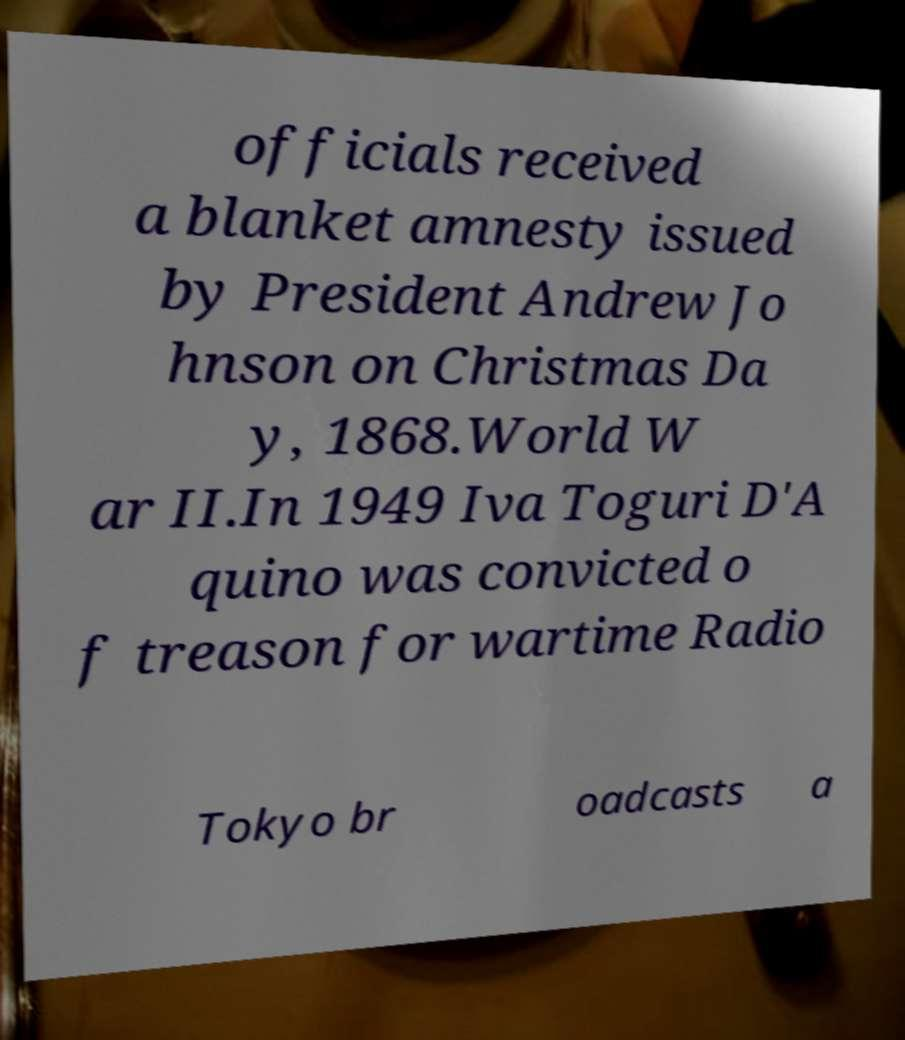What messages or text are displayed in this image? I need them in a readable, typed format. officials received a blanket amnesty issued by President Andrew Jo hnson on Christmas Da y, 1868.World W ar II.In 1949 Iva Toguri D'A quino was convicted o f treason for wartime Radio Tokyo br oadcasts a 